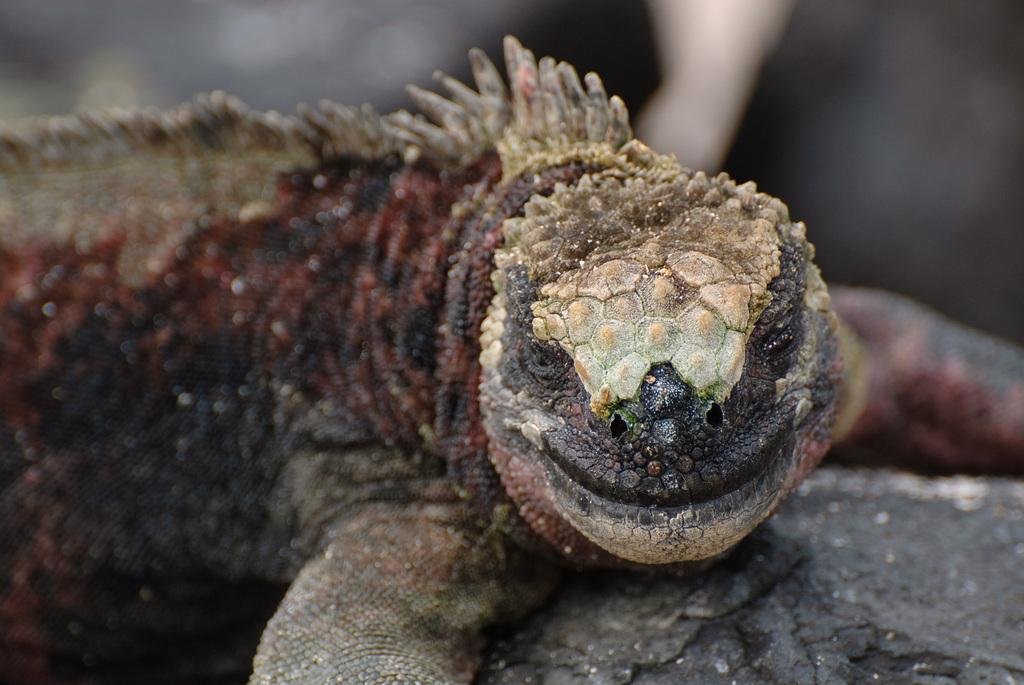What type of animal is in the image? There is a gila monster in the image. What surface is the gila monster on? The gila monster is on wood. Can you describe the background of the image? There might be trees visible at the top of the image. What type of skirt is the gila monster wearing in the image? The gila monster is not wearing a skirt, as it is an animal and not a person. 